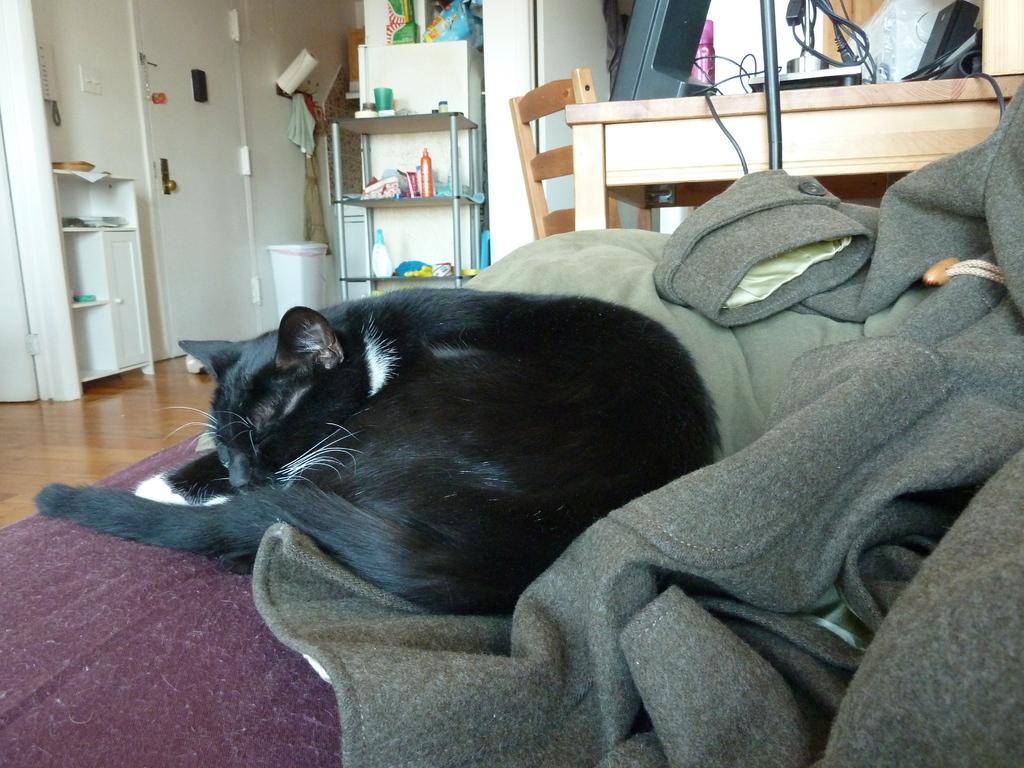In one or two sentences, can you explain what this image depicts? This is a picture taken in the house. In the foreground of the picture there is a cat sleeping on some clothes. To the top right there is a desk and a chair, on the disk there are cables and speakers. To the top of the background there closet and wall. In the closet there are some bottles. On the left there is a door, a dustbin and tissue paper. 